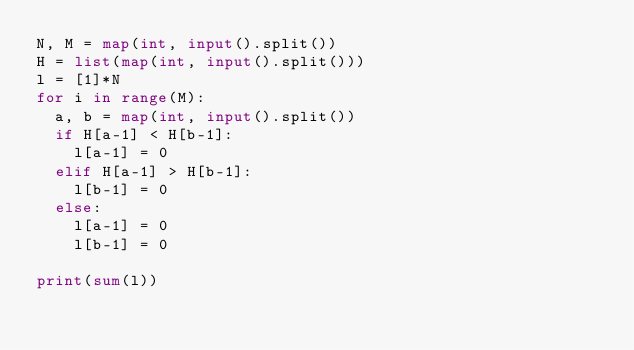Convert code to text. <code><loc_0><loc_0><loc_500><loc_500><_Python_>N, M = map(int, input().split())
H = list(map(int, input().split()))
l = [1]*N
for i in range(M):
  a, b = map(int, input().split())
  if H[a-1] < H[b-1]:
    l[a-1] = 0
  elif H[a-1] > H[b-1]:
    l[b-1] = 0
  else:
    l[a-1] = 0
    l[b-1] = 0
    
print(sum(l))</code> 